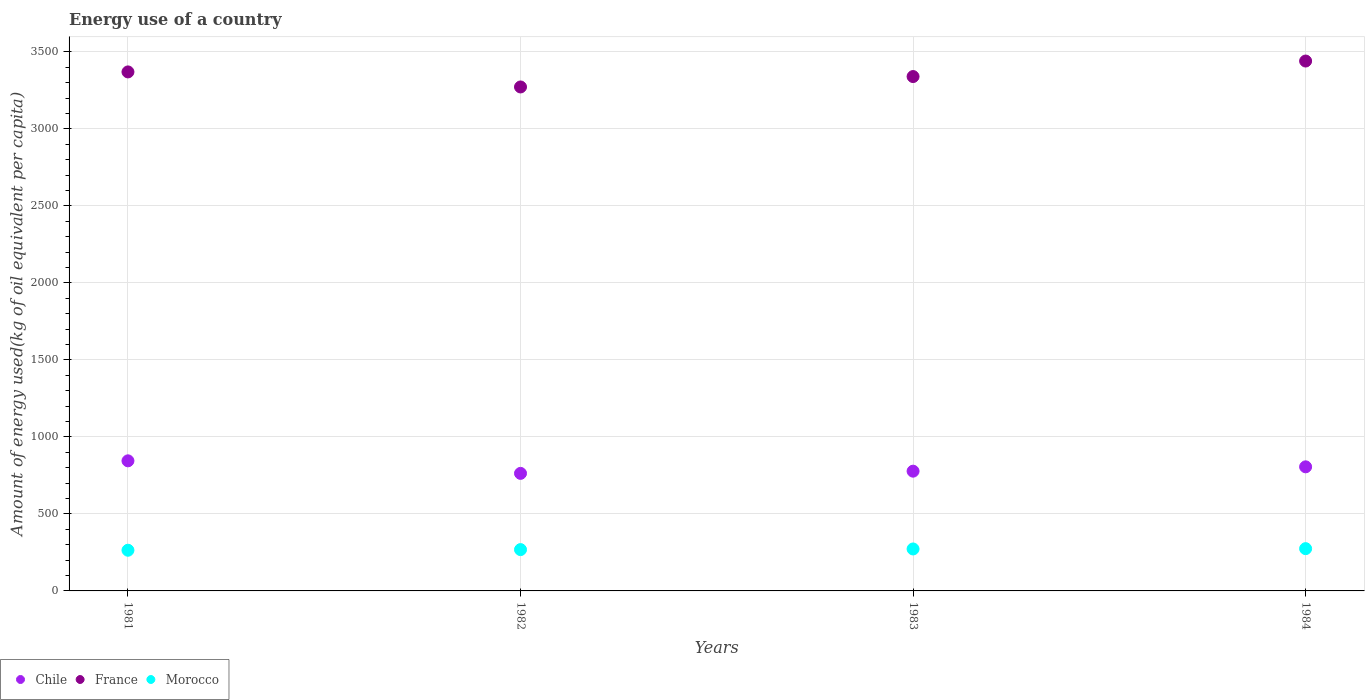How many different coloured dotlines are there?
Your response must be concise. 3. Is the number of dotlines equal to the number of legend labels?
Make the answer very short. Yes. What is the amount of energy used in in France in 1984?
Keep it short and to the point. 3440.37. Across all years, what is the maximum amount of energy used in in Chile?
Keep it short and to the point. 844.62. Across all years, what is the minimum amount of energy used in in Chile?
Your response must be concise. 763.2. In which year was the amount of energy used in in Chile maximum?
Your answer should be compact. 1981. What is the total amount of energy used in in Morocco in the graph?
Ensure brevity in your answer.  1079.25. What is the difference between the amount of energy used in in Chile in 1981 and that in 1982?
Your answer should be very brief. 81.42. What is the difference between the amount of energy used in in France in 1983 and the amount of energy used in in Chile in 1982?
Offer a terse response. 2576.43. What is the average amount of energy used in in Morocco per year?
Give a very brief answer. 269.81. In the year 1984, what is the difference between the amount of energy used in in Morocco and amount of energy used in in Chile?
Offer a terse response. -531.24. What is the ratio of the amount of energy used in in France in 1981 to that in 1982?
Make the answer very short. 1.03. What is the difference between the highest and the second highest amount of energy used in in France?
Make the answer very short. 70.66. What is the difference between the highest and the lowest amount of energy used in in Chile?
Offer a terse response. 81.42. In how many years, is the amount of energy used in in Morocco greater than the average amount of energy used in in Morocco taken over all years?
Provide a short and direct response. 2. Is the amount of energy used in in France strictly greater than the amount of energy used in in Chile over the years?
Give a very brief answer. Yes. Are the values on the major ticks of Y-axis written in scientific E-notation?
Provide a succinct answer. No. Does the graph contain any zero values?
Keep it short and to the point. No. Does the graph contain grids?
Offer a very short reply. Yes. Where does the legend appear in the graph?
Make the answer very short. Bottom left. How are the legend labels stacked?
Ensure brevity in your answer.  Horizontal. What is the title of the graph?
Keep it short and to the point. Energy use of a country. What is the label or title of the Y-axis?
Provide a short and direct response. Amount of energy used(kg of oil equivalent per capita). What is the Amount of energy used(kg of oil equivalent per capita) of Chile in 1981?
Your response must be concise. 844.62. What is the Amount of energy used(kg of oil equivalent per capita) in France in 1981?
Your answer should be very brief. 3369.71. What is the Amount of energy used(kg of oil equivalent per capita) in Morocco in 1981?
Ensure brevity in your answer.  264.12. What is the Amount of energy used(kg of oil equivalent per capita) of Chile in 1982?
Provide a short and direct response. 763.2. What is the Amount of energy used(kg of oil equivalent per capita) of France in 1982?
Keep it short and to the point. 3272.05. What is the Amount of energy used(kg of oil equivalent per capita) of Morocco in 1982?
Your answer should be compact. 268.26. What is the Amount of energy used(kg of oil equivalent per capita) of Chile in 1983?
Give a very brief answer. 777.5. What is the Amount of energy used(kg of oil equivalent per capita) of France in 1983?
Provide a succinct answer. 3339.63. What is the Amount of energy used(kg of oil equivalent per capita) of Morocco in 1983?
Your answer should be very brief. 272.42. What is the Amount of energy used(kg of oil equivalent per capita) in Chile in 1984?
Offer a very short reply. 805.69. What is the Amount of energy used(kg of oil equivalent per capita) of France in 1984?
Provide a short and direct response. 3440.37. What is the Amount of energy used(kg of oil equivalent per capita) of Morocco in 1984?
Ensure brevity in your answer.  274.45. Across all years, what is the maximum Amount of energy used(kg of oil equivalent per capita) of Chile?
Give a very brief answer. 844.62. Across all years, what is the maximum Amount of energy used(kg of oil equivalent per capita) in France?
Your answer should be compact. 3440.37. Across all years, what is the maximum Amount of energy used(kg of oil equivalent per capita) in Morocco?
Your response must be concise. 274.45. Across all years, what is the minimum Amount of energy used(kg of oil equivalent per capita) of Chile?
Your response must be concise. 763.2. Across all years, what is the minimum Amount of energy used(kg of oil equivalent per capita) in France?
Provide a short and direct response. 3272.05. Across all years, what is the minimum Amount of energy used(kg of oil equivalent per capita) in Morocco?
Keep it short and to the point. 264.12. What is the total Amount of energy used(kg of oil equivalent per capita) of Chile in the graph?
Ensure brevity in your answer.  3191. What is the total Amount of energy used(kg of oil equivalent per capita) of France in the graph?
Make the answer very short. 1.34e+04. What is the total Amount of energy used(kg of oil equivalent per capita) in Morocco in the graph?
Give a very brief answer. 1079.25. What is the difference between the Amount of energy used(kg of oil equivalent per capita) in Chile in 1981 and that in 1982?
Keep it short and to the point. 81.42. What is the difference between the Amount of energy used(kg of oil equivalent per capita) in France in 1981 and that in 1982?
Ensure brevity in your answer.  97.66. What is the difference between the Amount of energy used(kg of oil equivalent per capita) of Morocco in 1981 and that in 1982?
Offer a terse response. -4.14. What is the difference between the Amount of energy used(kg of oil equivalent per capita) of Chile in 1981 and that in 1983?
Your answer should be compact. 67.12. What is the difference between the Amount of energy used(kg of oil equivalent per capita) in France in 1981 and that in 1983?
Offer a terse response. 30.08. What is the difference between the Amount of energy used(kg of oil equivalent per capita) of Morocco in 1981 and that in 1983?
Make the answer very short. -8.3. What is the difference between the Amount of energy used(kg of oil equivalent per capita) in Chile in 1981 and that in 1984?
Keep it short and to the point. 38.93. What is the difference between the Amount of energy used(kg of oil equivalent per capita) in France in 1981 and that in 1984?
Keep it short and to the point. -70.66. What is the difference between the Amount of energy used(kg of oil equivalent per capita) of Morocco in 1981 and that in 1984?
Your answer should be very brief. -10.33. What is the difference between the Amount of energy used(kg of oil equivalent per capita) of Chile in 1982 and that in 1983?
Provide a succinct answer. -14.29. What is the difference between the Amount of energy used(kg of oil equivalent per capita) in France in 1982 and that in 1983?
Provide a succinct answer. -67.58. What is the difference between the Amount of energy used(kg of oil equivalent per capita) in Morocco in 1982 and that in 1983?
Make the answer very short. -4.16. What is the difference between the Amount of energy used(kg of oil equivalent per capita) in Chile in 1982 and that in 1984?
Offer a terse response. -42.48. What is the difference between the Amount of energy used(kg of oil equivalent per capita) in France in 1982 and that in 1984?
Offer a terse response. -168.32. What is the difference between the Amount of energy used(kg of oil equivalent per capita) in Morocco in 1982 and that in 1984?
Your response must be concise. -6.2. What is the difference between the Amount of energy used(kg of oil equivalent per capita) in Chile in 1983 and that in 1984?
Provide a succinct answer. -28.19. What is the difference between the Amount of energy used(kg of oil equivalent per capita) of France in 1983 and that in 1984?
Offer a very short reply. -100.74. What is the difference between the Amount of energy used(kg of oil equivalent per capita) of Morocco in 1983 and that in 1984?
Offer a very short reply. -2.03. What is the difference between the Amount of energy used(kg of oil equivalent per capita) of Chile in 1981 and the Amount of energy used(kg of oil equivalent per capita) of France in 1982?
Offer a terse response. -2427.44. What is the difference between the Amount of energy used(kg of oil equivalent per capita) of Chile in 1981 and the Amount of energy used(kg of oil equivalent per capita) of Morocco in 1982?
Your response must be concise. 576.36. What is the difference between the Amount of energy used(kg of oil equivalent per capita) in France in 1981 and the Amount of energy used(kg of oil equivalent per capita) in Morocco in 1982?
Offer a terse response. 3101.45. What is the difference between the Amount of energy used(kg of oil equivalent per capita) in Chile in 1981 and the Amount of energy used(kg of oil equivalent per capita) in France in 1983?
Offer a terse response. -2495.02. What is the difference between the Amount of energy used(kg of oil equivalent per capita) in Chile in 1981 and the Amount of energy used(kg of oil equivalent per capita) in Morocco in 1983?
Offer a very short reply. 572.2. What is the difference between the Amount of energy used(kg of oil equivalent per capita) of France in 1981 and the Amount of energy used(kg of oil equivalent per capita) of Morocco in 1983?
Your answer should be very brief. 3097.29. What is the difference between the Amount of energy used(kg of oil equivalent per capita) of Chile in 1981 and the Amount of energy used(kg of oil equivalent per capita) of France in 1984?
Make the answer very short. -2595.76. What is the difference between the Amount of energy used(kg of oil equivalent per capita) in Chile in 1981 and the Amount of energy used(kg of oil equivalent per capita) in Morocco in 1984?
Ensure brevity in your answer.  570.17. What is the difference between the Amount of energy used(kg of oil equivalent per capita) in France in 1981 and the Amount of energy used(kg of oil equivalent per capita) in Morocco in 1984?
Ensure brevity in your answer.  3095.26. What is the difference between the Amount of energy used(kg of oil equivalent per capita) in Chile in 1982 and the Amount of energy used(kg of oil equivalent per capita) in France in 1983?
Give a very brief answer. -2576.43. What is the difference between the Amount of energy used(kg of oil equivalent per capita) in Chile in 1982 and the Amount of energy used(kg of oil equivalent per capita) in Morocco in 1983?
Your answer should be compact. 490.78. What is the difference between the Amount of energy used(kg of oil equivalent per capita) in France in 1982 and the Amount of energy used(kg of oil equivalent per capita) in Morocco in 1983?
Your response must be concise. 2999.63. What is the difference between the Amount of energy used(kg of oil equivalent per capita) of Chile in 1982 and the Amount of energy used(kg of oil equivalent per capita) of France in 1984?
Ensure brevity in your answer.  -2677.17. What is the difference between the Amount of energy used(kg of oil equivalent per capita) of Chile in 1982 and the Amount of energy used(kg of oil equivalent per capita) of Morocco in 1984?
Provide a short and direct response. 488.75. What is the difference between the Amount of energy used(kg of oil equivalent per capita) in France in 1982 and the Amount of energy used(kg of oil equivalent per capita) in Morocco in 1984?
Provide a short and direct response. 2997.6. What is the difference between the Amount of energy used(kg of oil equivalent per capita) of Chile in 1983 and the Amount of energy used(kg of oil equivalent per capita) of France in 1984?
Offer a terse response. -2662.88. What is the difference between the Amount of energy used(kg of oil equivalent per capita) of Chile in 1983 and the Amount of energy used(kg of oil equivalent per capita) of Morocco in 1984?
Offer a terse response. 503.04. What is the difference between the Amount of energy used(kg of oil equivalent per capita) of France in 1983 and the Amount of energy used(kg of oil equivalent per capita) of Morocco in 1984?
Your response must be concise. 3065.18. What is the average Amount of energy used(kg of oil equivalent per capita) of Chile per year?
Offer a terse response. 797.75. What is the average Amount of energy used(kg of oil equivalent per capita) of France per year?
Give a very brief answer. 3355.44. What is the average Amount of energy used(kg of oil equivalent per capita) of Morocco per year?
Make the answer very short. 269.81. In the year 1981, what is the difference between the Amount of energy used(kg of oil equivalent per capita) of Chile and Amount of energy used(kg of oil equivalent per capita) of France?
Provide a succinct answer. -2525.09. In the year 1981, what is the difference between the Amount of energy used(kg of oil equivalent per capita) in Chile and Amount of energy used(kg of oil equivalent per capita) in Morocco?
Provide a succinct answer. 580.5. In the year 1981, what is the difference between the Amount of energy used(kg of oil equivalent per capita) of France and Amount of energy used(kg of oil equivalent per capita) of Morocco?
Provide a short and direct response. 3105.59. In the year 1982, what is the difference between the Amount of energy used(kg of oil equivalent per capita) of Chile and Amount of energy used(kg of oil equivalent per capita) of France?
Offer a very short reply. -2508.85. In the year 1982, what is the difference between the Amount of energy used(kg of oil equivalent per capita) of Chile and Amount of energy used(kg of oil equivalent per capita) of Morocco?
Your response must be concise. 494.95. In the year 1982, what is the difference between the Amount of energy used(kg of oil equivalent per capita) of France and Amount of energy used(kg of oil equivalent per capita) of Morocco?
Provide a succinct answer. 3003.8. In the year 1983, what is the difference between the Amount of energy used(kg of oil equivalent per capita) of Chile and Amount of energy used(kg of oil equivalent per capita) of France?
Offer a terse response. -2562.14. In the year 1983, what is the difference between the Amount of energy used(kg of oil equivalent per capita) of Chile and Amount of energy used(kg of oil equivalent per capita) of Morocco?
Provide a succinct answer. 505.08. In the year 1983, what is the difference between the Amount of energy used(kg of oil equivalent per capita) of France and Amount of energy used(kg of oil equivalent per capita) of Morocco?
Provide a succinct answer. 3067.21. In the year 1984, what is the difference between the Amount of energy used(kg of oil equivalent per capita) of Chile and Amount of energy used(kg of oil equivalent per capita) of France?
Offer a very short reply. -2634.69. In the year 1984, what is the difference between the Amount of energy used(kg of oil equivalent per capita) in Chile and Amount of energy used(kg of oil equivalent per capita) in Morocco?
Your answer should be compact. 531.24. In the year 1984, what is the difference between the Amount of energy used(kg of oil equivalent per capita) in France and Amount of energy used(kg of oil equivalent per capita) in Morocco?
Make the answer very short. 3165.92. What is the ratio of the Amount of energy used(kg of oil equivalent per capita) in Chile in 1981 to that in 1982?
Provide a short and direct response. 1.11. What is the ratio of the Amount of energy used(kg of oil equivalent per capita) of France in 1981 to that in 1982?
Provide a short and direct response. 1.03. What is the ratio of the Amount of energy used(kg of oil equivalent per capita) in Morocco in 1981 to that in 1982?
Keep it short and to the point. 0.98. What is the ratio of the Amount of energy used(kg of oil equivalent per capita) of Chile in 1981 to that in 1983?
Ensure brevity in your answer.  1.09. What is the ratio of the Amount of energy used(kg of oil equivalent per capita) in France in 1981 to that in 1983?
Offer a very short reply. 1.01. What is the ratio of the Amount of energy used(kg of oil equivalent per capita) of Morocco in 1981 to that in 1983?
Provide a short and direct response. 0.97. What is the ratio of the Amount of energy used(kg of oil equivalent per capita) of Chile in 1981 to that in 1984?
Make the answer very short. 1.05. What is the ratio of the Amount of energy used(kg of oil equivalent per capita) in France in 1981 to that in 1984?
Your response must be concise. 0.98. What is the ratio of the Amount of energy used(kg of oil equivalent per capita) of Morocco in 1981 to that in 1984?
Your answer should be very brief. 0.96. What is the ratio of the Amount of energy used(kg of oil equivalent per capita) in Chile in 1982 to that in 1983?
Give a very brief answer. 0.98. What is the ratio of the Amount of energy used(kg of oil equivalent per capita) in France in 1982 to that in 1983?
Your answer should be compact. 0.98. What is the ratio of the Amount of energy used(kg of oil equivalent per capita) in Morocco in 1982 to that in 1983?
Make the answer very short. 0.98. What is the ratio of the Amount of energy used(kg of oil equivalent per capita) in Chile in 1982 to that in 1984?
Give a very brief answer. 0.95. What is the ratio of the Amount of energy used(kg of oil equivalent per capita) of France in 1982 to that in 1984?
Your answer should be compact. 0.95. What is the ratio of the Amount of energy used(kg of oil equivalent per capita) of Morocco in 1982 to that in 1984?
Ensure brevity in your answer.  0.98. What is the ratio of the Amount of energy used(kg of oil equivalent per capita) of France in 1983 to that in 1984?
Provide a succinct answer. 0.97. What is the difference between the highest and the second highest Amount of energy used(kg of oil equivalent per capita) of Chile?
Your answer should be very brief. 38.93. What is the difference between the highest and the second highest Amount of energy used(kg of oil equivalent per capita) in France?
Offer a very short reply. 70.66. What is the difference between the highest and the second highest Amount of energy used(kg of oil equivalent per capita) in Morocco?
Provide a succinct answer. 2.03. What is the difference between the highest and the lowest Amount of energy used(kg of oil equivalent per capita) in Chile?
Make the answer very short. 81.42. What is the difference between the highest and the lowest Amount of energy used(kg of oil equivalent per capita) of France?
Offer a terse response. 168.32. What is the difference between the highest and the lowest Amount of energy used(kg of oil equivalent per capita) in Morocco?
Provide a short and direct response. 10.33. 